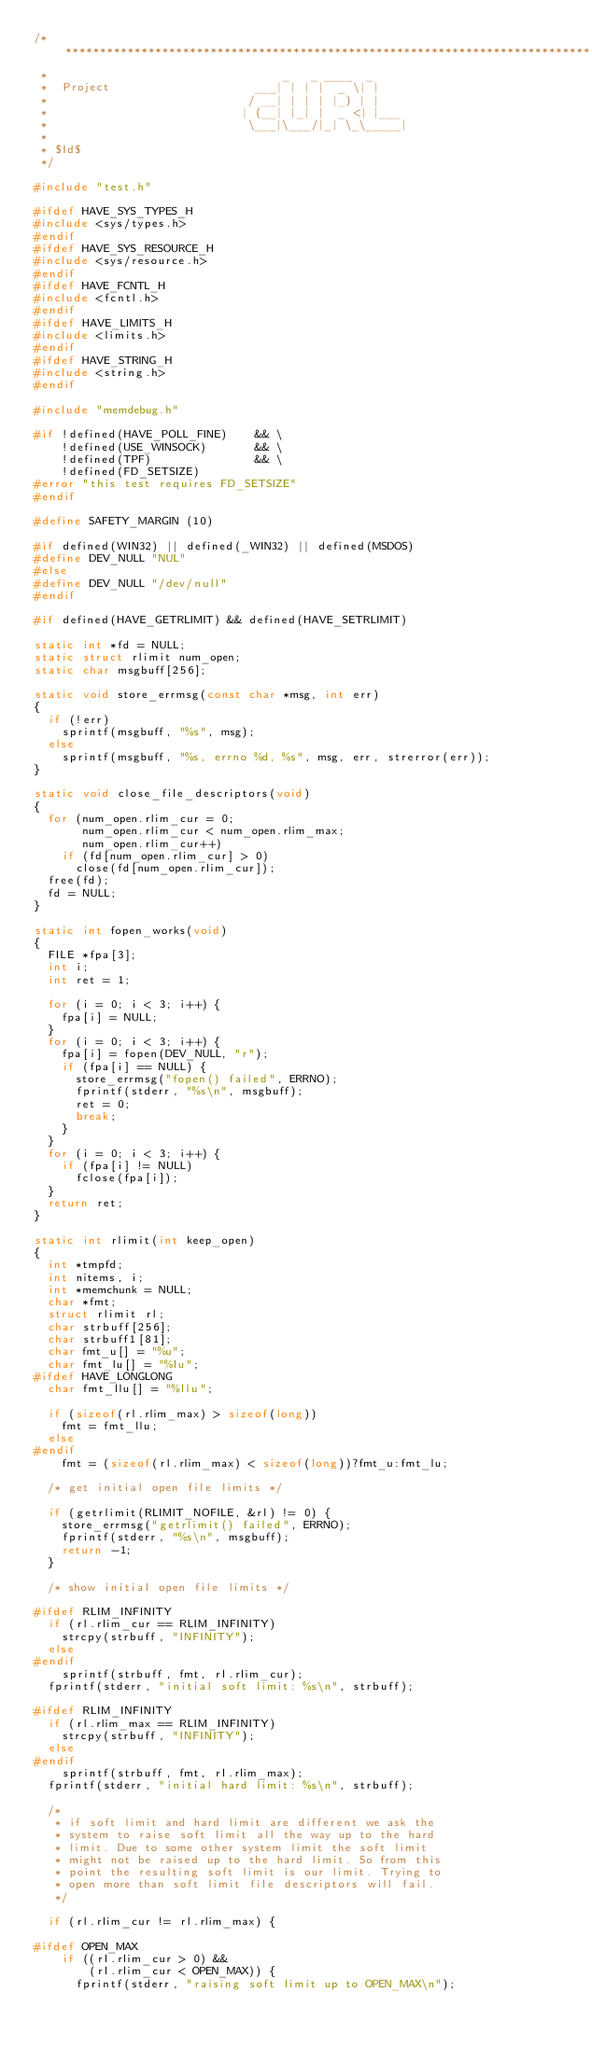<code> <loc_0><loc_0><loc_500><loc_500><_C_>/*****************************************************************************
 *                                  _   _ ____  _
 *  Project                     ___| | | |  _ \| |
 *                             / __| | | | |_) | |
 *                            | (__| |_| |  _ <| |___
 *                             \___|\___/|_| \_\_____|
 *
 * $Id$
 */

#include "test.h"

#ifdef HAVE_SYS_TYPES_H
#include <sys/types.h>
#endif
#ifdef HAVE_SYS_RESOURCE_H
#include <sys/resource.h>
#endif
#ifdef HAVE_FCNTL_H
#include <fcntl.h>
#endif
#ifdef HAVE_LIMITS_H
#include <limits.h>
#endif
#ifdef HAVE_STRING_H
#include <string.h>
#endif

#include "memdebug.h"

#if !defined(HAVE_POLL_FINE)    && \
    !defined(USE_WINSOCK)       && \
    !defined(TPF)               && \
    !defined(FD_SETSIZE)
#error "this test requires FD_SETSIZE"
#endif

#define SAFETY_MARGIN (10)

#if defined(WIN32) || defined(_WIN32) || defined(MSDOS)
#define DEV_NULL "NUL"
#else
#define DEV_NULL "/dev/null"
#endif

#if defined(HAVE_GETRLIMIT) && defined(HAVE_SETRLIMIT)

static int *fd = NULL;
static struct rlimit num_open;
static char msgbuff[256];

static void store_errmsg(const char *msg, int err)
{
  if (!err)
    sprintf(msgbuff, "%s", msg);
  else
    sprintf(msgbuff, "%s, errno %d, %s", msg, err, strerror(err));
}

static void close_file_descriptors(void)
{
  for (num_open.rlim_cur = 0;
       num_open.rlim_cur < num_open.rlim_max;
       num_open.rlim_cur++)
    if (fd[num_open.rlim_cur] > 0)
      close(fd[num_open.rlim_cur]);
  free(fd);
  fd = NULL;
}

static int fopen_works(void)
{
  FILE *fpa[3];
  int i;
  int ret = 1;

  for (i = 0; i < 3; i++) {
    fpa[i] = NULL;
  }
  for (i = 0; i < 3; i++) {
    fpa[i] = fopen(DEV_NULL, "r");
    if (fpa[i] == NULL) {
      store_errmsg("fopen() failed", ERRNO);
      fprintf(stderr, "%s\n", msgbuff);
      ret = 0;
      break;
    }
  }
  for (i = 0; i < 3; i++) {
    if (fpa[i] != NULL)
      fclose(fpa[i]);
  }
  return ret;
}

static int rlimit(int keep_open)
{
  int *tmpfd;
  int nitems, i;
  int *memchunk = NULL;
  char *fmt;
  struct rlimit rl;
  char strbuff[256];
  char strbuff1[81];
  char fmt_u[] = "%u";
  char fmt_lu[] = "%lu";
#ifdef HAVE_LONGLONG
  char fmt_llu[] = "%llu";

  if (sizeof(rl.rlim_max) > sizeof(long))
    fmt = fmt_llu;
  else
#endif
    fmt = (sizeof(rl.rlim_max) < sizeof(long))?fmt_u:fmt_lu;

  /* get initial open file limits */

  if (getrlimit(RLIMIT_NOFILE, &rl) != 0) {
    store_errmsg("getrlimit() failed", ERRNO);
    fprintf(stderr, "%s\n", msgbuff);
    return -1;
  }

  /* show initial open file limits */

#ifdef RLIM_INFINITY
  if (rl.rlim_cur == RLIM_INFINITY)
    strcpy(strbuff, "INFINITY");
  else
#endif
    sprintf(strbuff, fmt, rl.rlim_cur);
  fprintf(stderr, "initial soft limit: %s\n", strbuff);

#ifdef RLIM_INFINITY
  if (rl.rlim_max == RLIM_INFINITY)
    strcpy(strbuff, "INFINITY");
  else
#endif
    sprintf(strbuff, fmt, rl.rlim_max);
  fprintf(stderr, "initial hard limit: %s\n", strbuff);

  /*
   * if soft limit and hard limit are different we ask the
   * system to raise soft limit all the way up to the hard
   * limit. Due to some other system limit the soft limit
   * might not be raised up to the hard limit. So from this
   * point the resulting soft limit is our limit. Trying to
   * open more than soft limit file descriptors will fail.
   */

  if (rl.rlim_cur != rl.rlim_max) {

#ifdef OPEN_MAX
    if ((rl.rlim_cur > 0) &&
        (rl.rlim_cur < OPEN_MAX)) {
      fprintf(stderr, "raising soft limit up to OPEN_MAX\n");</code> 